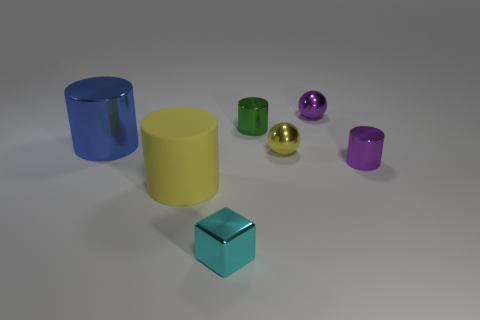Add 3 tiny red rubber blocks. How many objects exist? 10 Subtract all balls. How many objects are left? 5 Add 7 large purple metal spheres. How many large purple metal spheres exist? 7 Subtract 0 brown cylinders. How many objects are left? 7 Subtract all tiny metal things. Subtract all small yellow metal things. How many objects are left? 1 Add 6 purple metallic cylinders. How many purple metallic cylinders are left? 7 